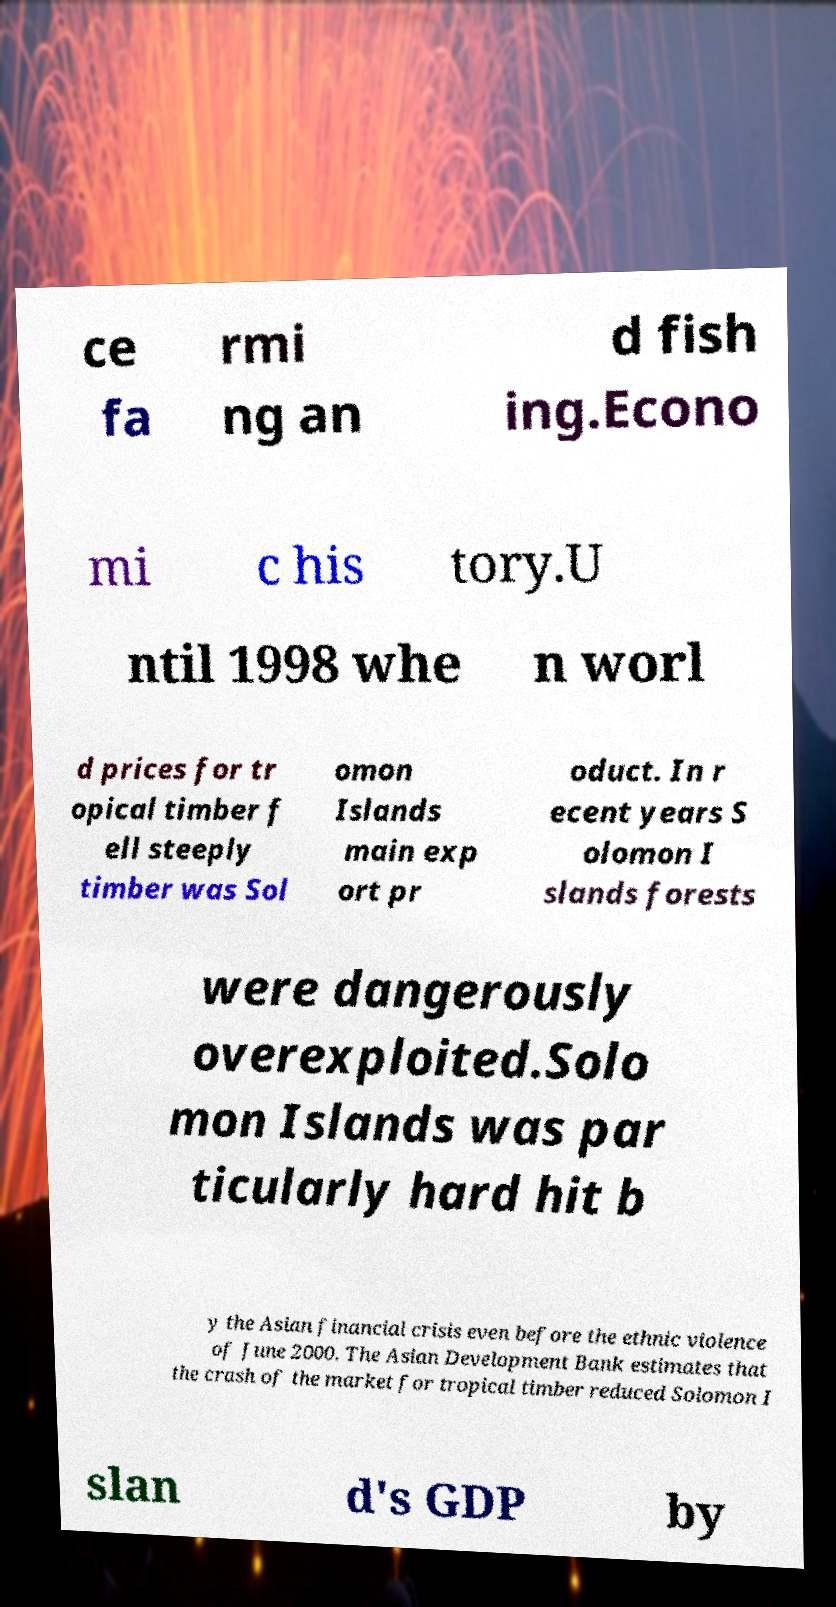Could you assist in decoding the text presented in this image and type it out clearly? ce fa rmi ng an d fish ing.Econo mi c his tory.U ntil 1998 whe n worl d prices for tr opical timber f ell steeply timber was Sol omon Islands main exp ort pr oduct. In r ecent years S olomon I slands forests were dangerously overexploited.Solo mon Islands was par ticularly hard hit b y the Asian financial crisis even before the ethnic violence of June 2000. The Asian Development Bank estimates that the crash of the market for tropical timber reduced Solomon I slan d's GDP by 